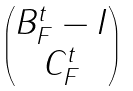<formula> <loc_0><loc_0><loc_500><loc_500>\begin{pmatrix} B _ { F } ^ { t } - I \\ C _ { F } ^ { t } \end{pmatrix}</formula> 